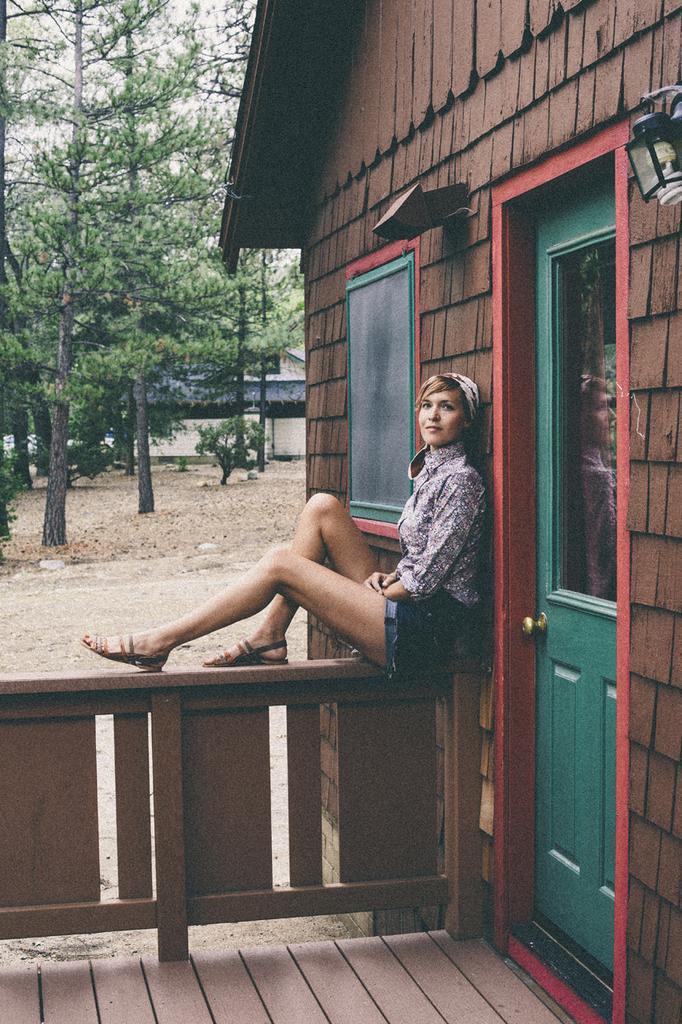Please provide a concise description of this image. In this image there is a woman sitting on a wooden wall, on the right side there is a house, in the background there are trees. 